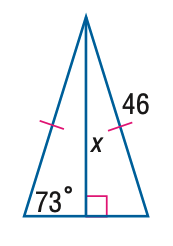Question: Find x. Round to the nearest tenth.
Choices:
A. 13.4
B. 31.1
C. 44.0
D. 46
Answer with the letter. Answer: C 